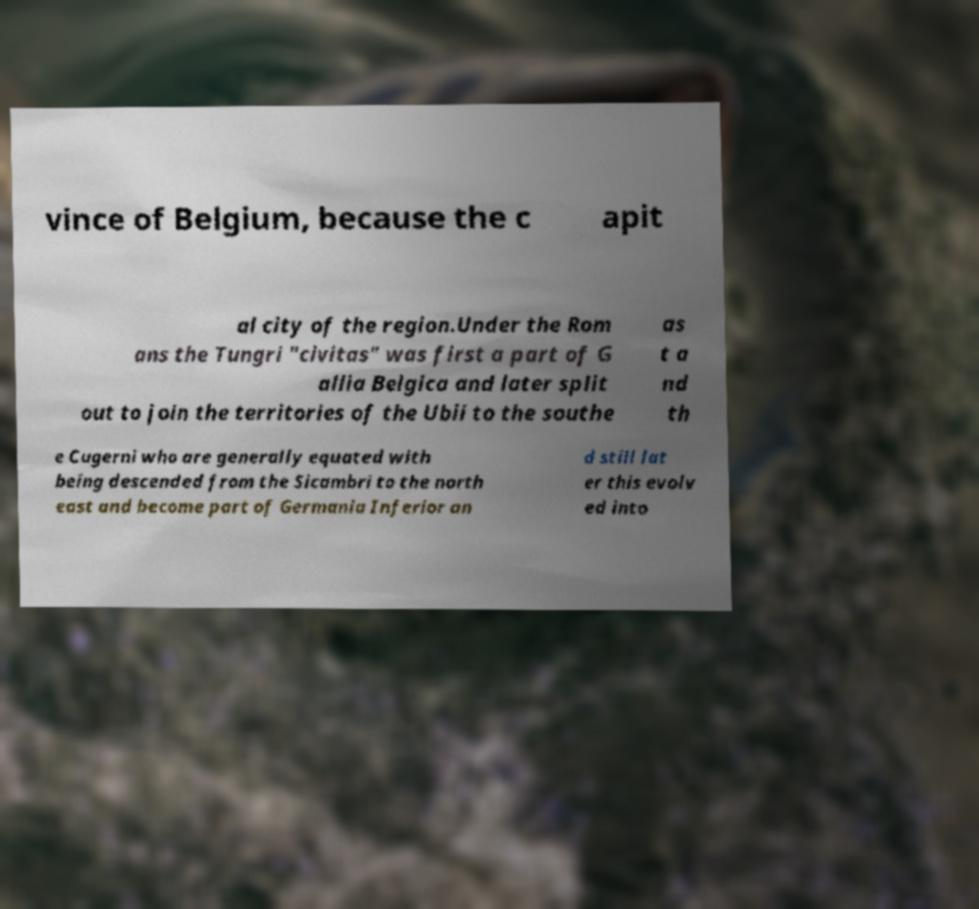There's text embedded in this image that I need extracted. Can you transcribe it verbatim? vince of Belgium, because the c apit al city of the region.Under the Rom ans the Tungri "civitas" was first a part of G allia Belgica and later split out to join the territories of the Ubii to the southe as t a nd th e Cugerni who are generally equated with being descended from the Sicambri to the north east and become part of Germania Inferior an d still lat er this evolv ed into 